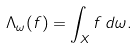<formula> <loc_0><loc_0><loc_500><loc_500>\Lambda _ { \omega } ( f ) = \int _ { X } f \, d \omega .</formula> 